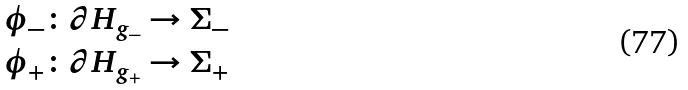<formula> <loc_0><loc_0><loc_500><loc_500>\phi _ { - } & \colon \partial H _ { g _ { - } } \rightarrow \Sigma _ { - } \\ \phi _ { + } & \colon \partial H _ { g _ { + } } \rightarrow \Sigma _ { + }</formula> 